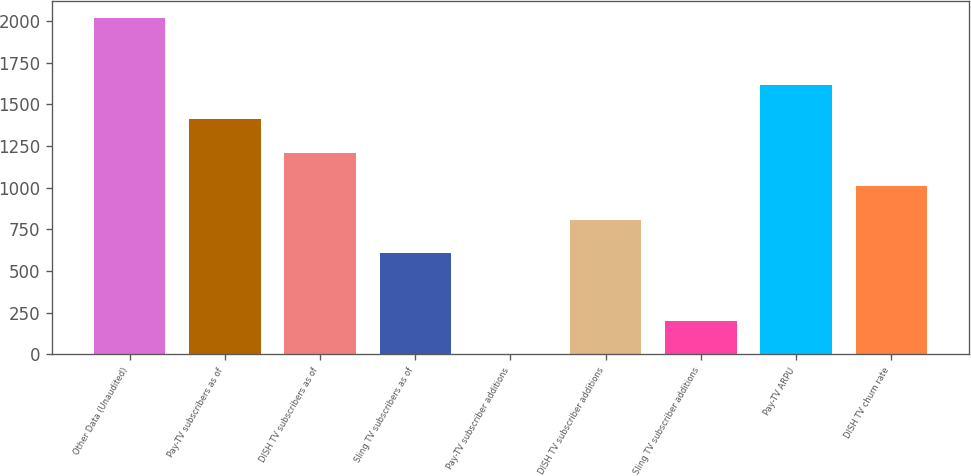<chart> <loc_0><loc_0><loc_500><loc_500><bar_chart><fcel>Other Data (Unaudited)<fcel>Pay-TV subscribers as of<fcel>DISH TV subscribers as of<fcel>Sling TV subscribers as of<fcel>Pay-TV subscriber additions<fcel>DISH TV subscriber additions<fcel>Sling TV subscriber additions<fcel>Pay-TV ARPU<fcel>DISH TV churn rate<nl><fcel>2016<fcel>1411.31<fcel>1209.75<fcel>605.07<fcel>0.39<fcel>806.63<fcel>201.95<fcel>1612.87<fcel>1008.19<nl></chart> 